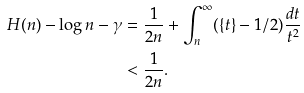<formula> <loc_0><loc_0><loc_500><loc_500>H ( n ) - \log n - \gamma & = \frac { 1 } { 2 n } + \int _ { n } ^ { \infty } ( \{ t \} - 1 / 2 ) \frac { d t } { t ^ { 2 } } \\ & < \frac { 1 } { 2 n } .</formula> 